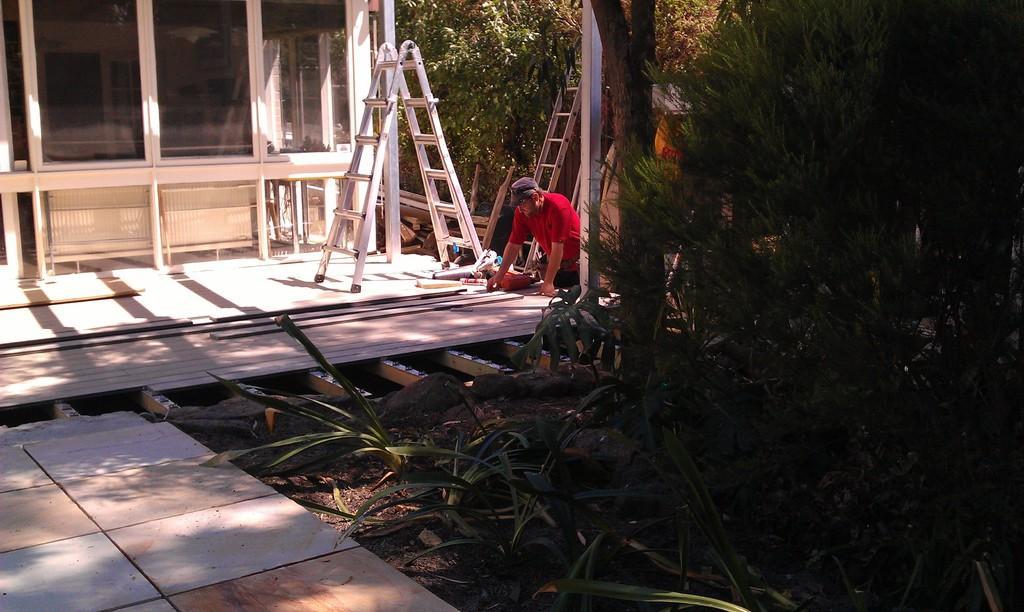Could you give a brief overview of what you see in this image? In this image we can see a building with windows. There are wooden pieces. There is a person wearing cap. Also there are ladders. And there are plants and trees. 